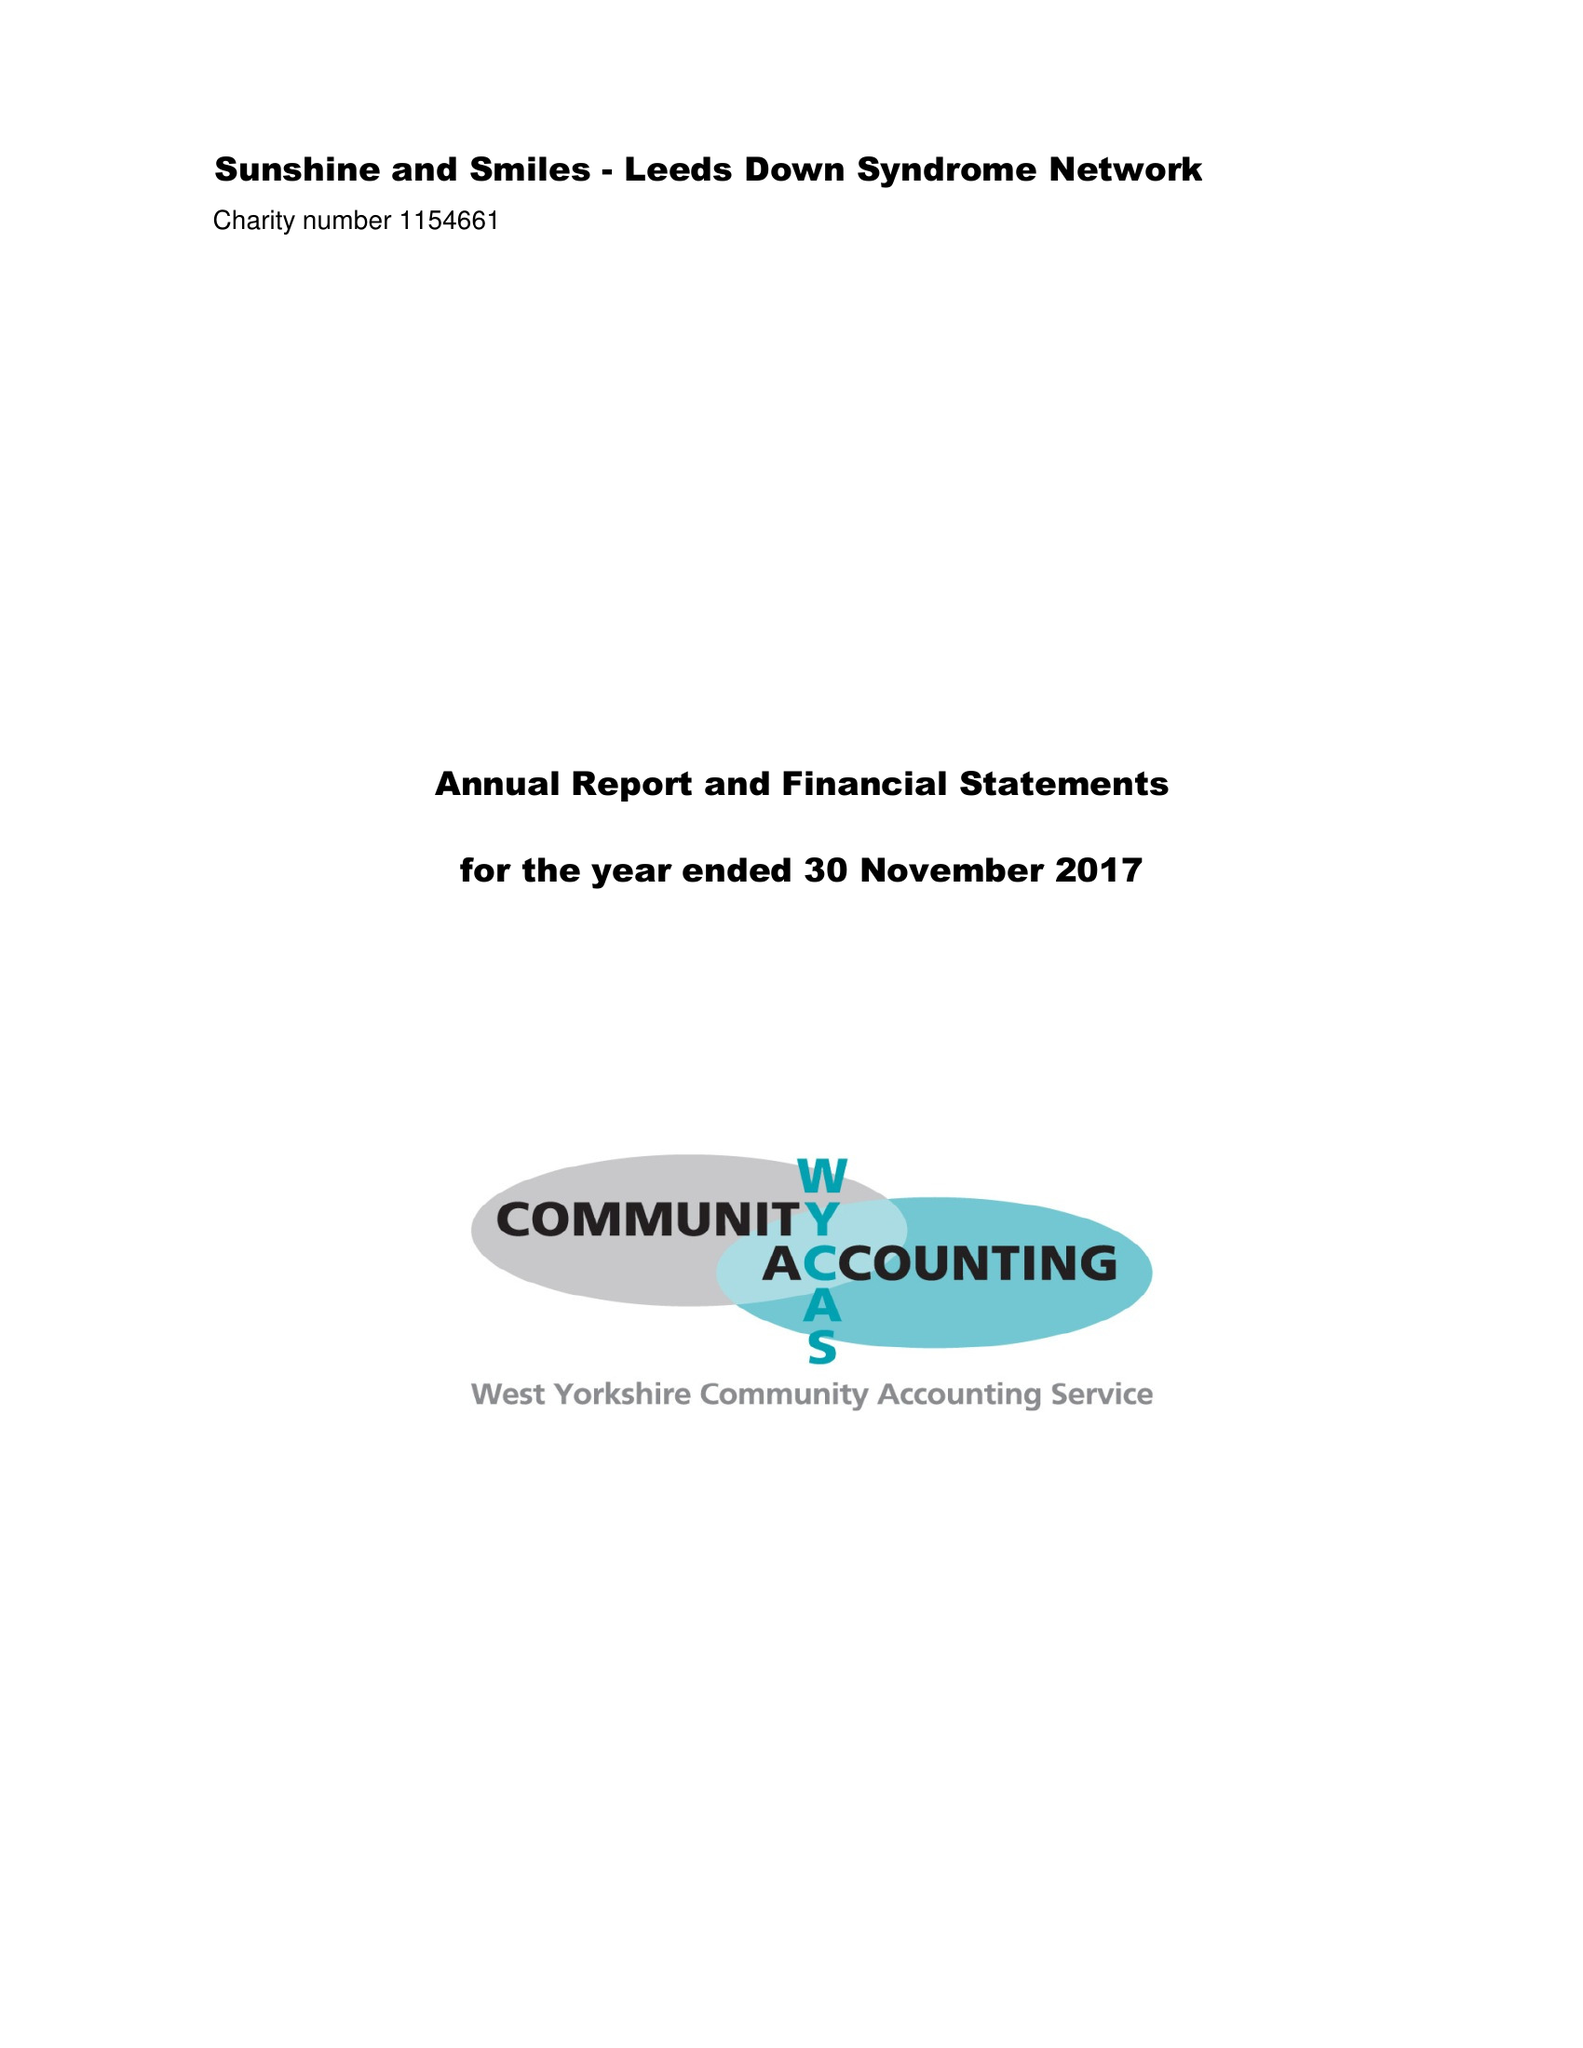What is the value for the address__postcode?
Answer the question using a single word or phrase. LS16 5LB 